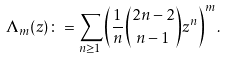Convert formula to latex. <formula><loc_0><loc_0><loc_500><loc_500>\Lambda _ { m } ( z ) \colon = \sum _ { n \geq 1 } \left ( \frac { 1 } { n } \binom { 2 n - 2 } { n - 1 } z ^ { n } \right ) ^ { m } .</formula> 